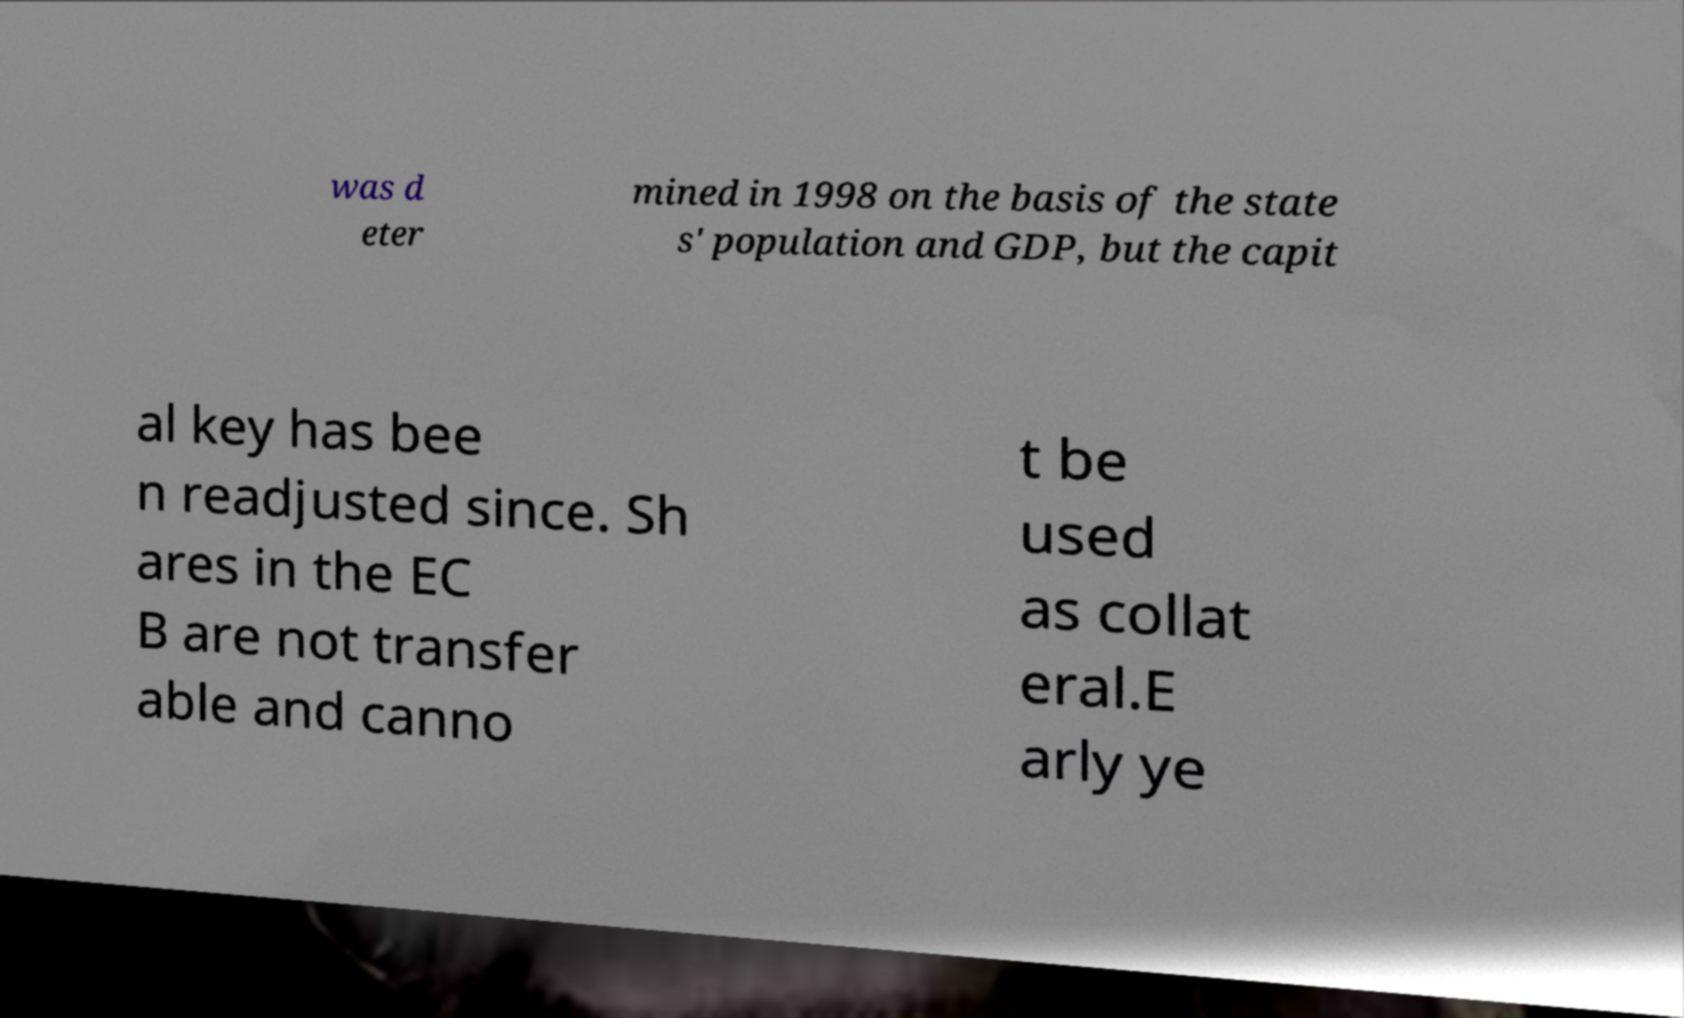For documentation purposes, I need the text within this image transcribed. Could you provide that? was d eter mined in 1998 on the basis of the state s' population and GDP, but the capit al key has bee n readjusted since. Sh ares in the EC B are not transfer able and canno t be used as collat eral.E arly ye 